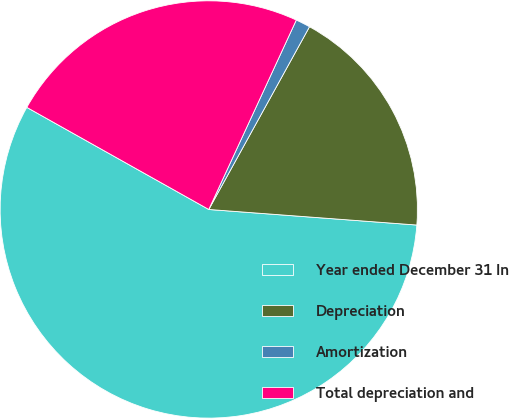Convert chart to OTSL. <chart><loc_0><loc_0><loc_500><loc_500><pie_chart><fcel>Year ended December 31 In<fcel>Depreciation<fcel>Amortization<fcel>Total depreciation and<nl><fcel>56.95%<fcel>18.17%<fcel>1.13%<fcel>23.75%<nl></chart> 